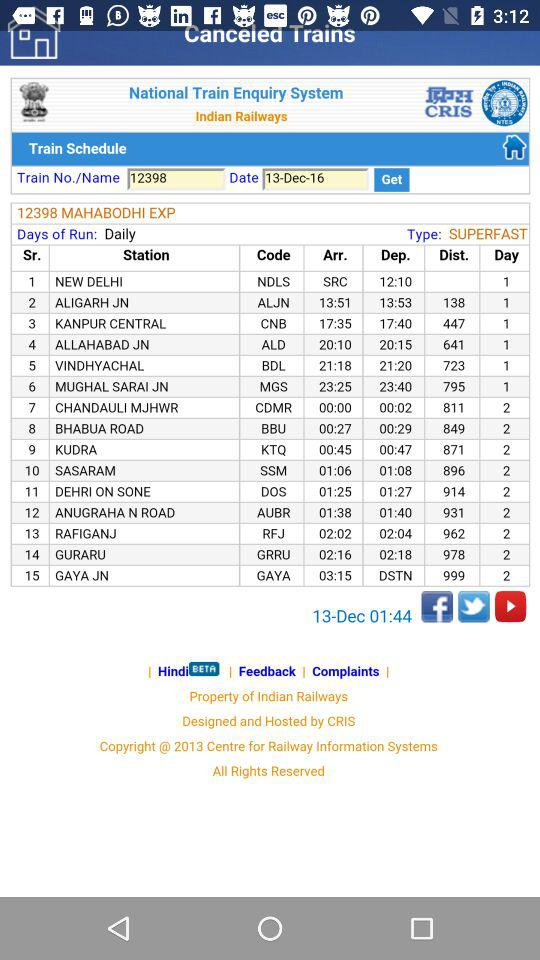What is the departure date? The departure date is December 13, 2016. 